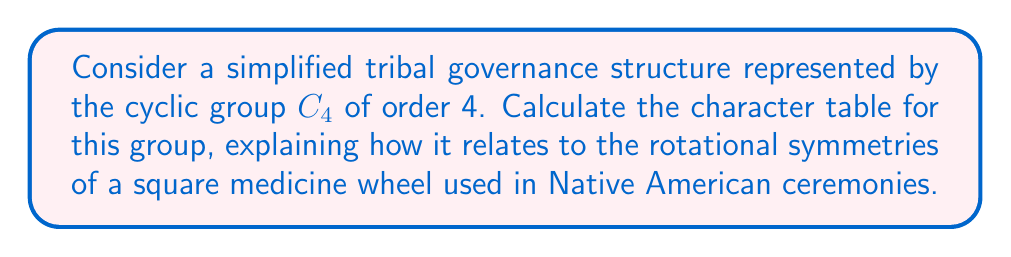Can you answer this question? 1) First, let's identify the elements of $C_4$. We can represent them as rotations of a square medicine wheel:
   $e$ (identity), $r$ (90° rotation), $r^2$ (180° rotation), $r^3$ (270° rotation)

2) $C_4$ has 4 conjugacy classes, each containing one element: $\{e\}$, $\{r\}$, $\{r^2\}$, $\{r^3\}$

3) The number of irreducible representations equals the number of conjugacy classes, so we need to find 4 irreducible representations.

4) For a cyclic group, all irreducible representations are one-dimensional. Let $\chi_j$ be the $j$-th irreducible character. We can express them as:

   $\chi_j(r^k) = (\omega^j)^k$, where $\omega = e^{2\pi i/4} = i$

5) Calculating the characters:
   $\chi_0(r^k) = 1^k = 1$ for all $k$ (trivial representation)
   $\chi_1(r^k) = i^k$
   $\chi_2(r^k) = (i^2)^k = (-1)^k$
   $\chi_3(r^k) = (i^3)^k = (-i)^k$

6) Now we can construct the character table:

   $$\begin{array}{c|cccc}
      C_4 & e & r & r^2 & r^3 \\
      \hline
      \chi_0 & 1 & 1 & 1 & 1 \\
      \chi_1 & 1 & i & -1 & -i \\
      \chi_2 & 1 & -1 & 1 & -1 \\
      \chi_3 & 1 & -i & -1 & i
   \end{array}$$

This character table represents how the different "leadership roles" (represented by group elements) transform under various "cultural perspectives" (represented by irreducible representations) in the tribal governance structure.
Answer: $$\begin{array}{c|cccc}
   C_4 & e & r & r^2 & r^3 \\
   \hline
   \chi_0 & 1 & 1 & 1 & 1 \\
   \chi_1 & 1 & i & -1 & -i \\
   \chi_2 & 1 & -1 & 1 & -1 \\
   \chi_3 & 1 & -i & -1 & i
\end{array}$$ 